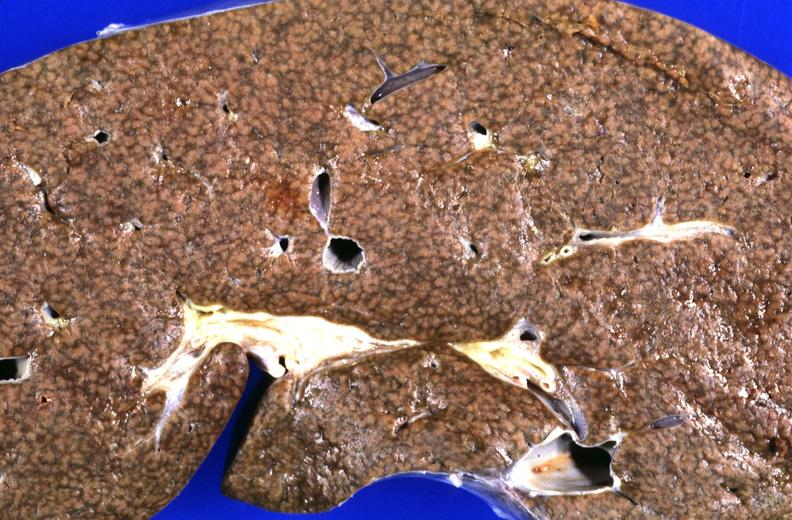what does this image show?
Answer the question using a single word or phrase. Liver 